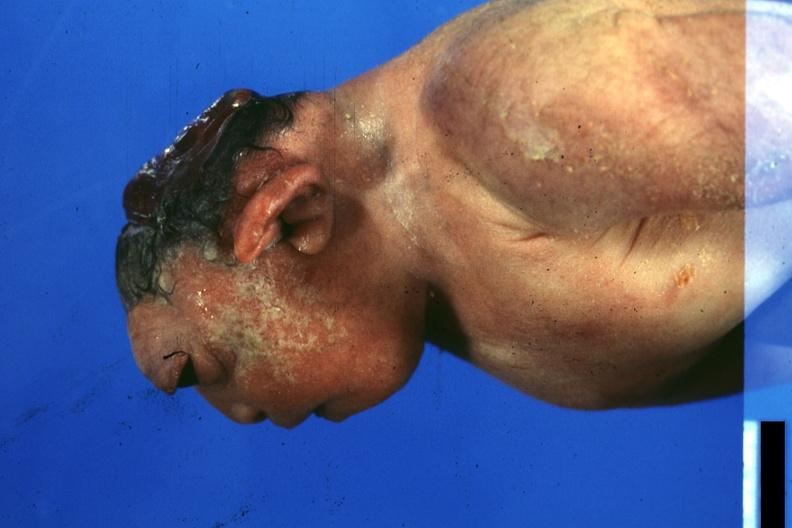what does this image show?
Answer the question using a single word or phrase. Lateral view of typical case 